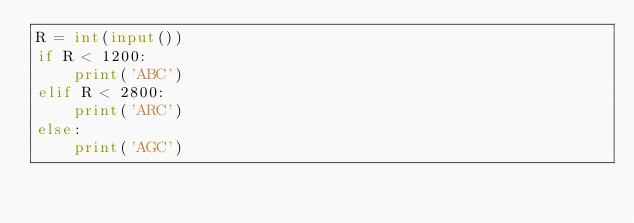Convert code to text. <code><loc_0><loc_0><loc_500><loc_500><_Python_>R = int(input())
if R < 1200:
    print('ABC')
elif R < 2800:
    print('ARC')
else:
    print('AGC')</code> 